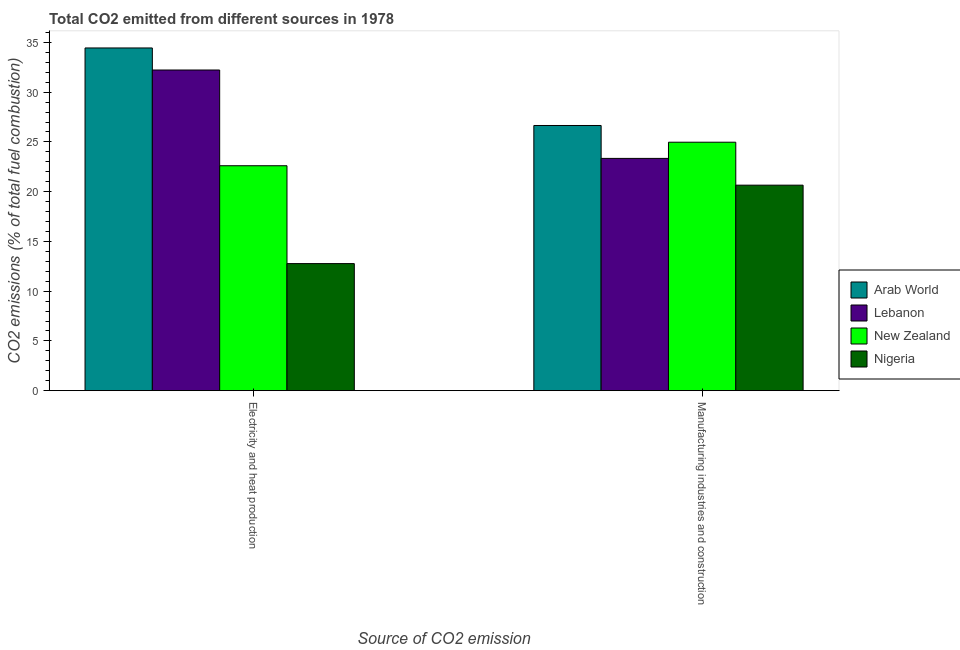How many different coloured bars are there?
Make the answer very short. 4. Are the number of bars per tick equal to the number of legend labels?
Give a very brief answer. Yes. Are the number of bars on each tick of the X-axis equal?
Offer a terse response. Yes. How many bars are there on the 2nd tick from the right?
Keep it short and to the point. 4. What is the label of the 2nd group of bars from the left?
Provide a short and direct response. Manufacturing industries and construction. What is the co2 emissions due to manufacturing industries in New Zealand?
Your answer should be compact. 24.97. Across all countries, what is the maximum co2 emissions due to electricity and heat production?
Provide a succinct answer. 34.45. Across all countries, what is the minimum co2 emissions due to electricity and heat production?
Give a very brief answer. 12.77. In which country was the co2 emissions due to electricity and heat production maximum?
Provide a short and direct response. Arab World. In which country was the co2 emissions due to manufacturing industries minimum?
Offer a terse response. Nigeria. What is the total co2 emissions due to electricity and heat production in the graph?
Offer a very short reply. 102.05. What is the difference between the co2 emissions due to electricity and heat production in Arab World and that in New Zealand?
Keep it short and to the point. 11.84. What is the difference between the co2 emissions due to manufacturing industries in Lebanon and the co2 emissions due to electricity and heat production in Arab World?
Your answer should be compact. -11.1. What is the average co2 emissions due to electricity and heat production per country?
Provide a short and direct response. 25.51. What is the difference between the co2 emissions due to electricity and heat production and co2 emissions due to manufacturing industries in Lebanon?
Provide a short and direct response. 8.89. What is the ratio of the co2 emissions due to manufacturing industries in Nigeria to that in Lebanon?
Offer a terse response. 0.88. What does the 3rd bar from the left in Manufacturing industries and construction represents?
Provide a succinct answer. New Zealand. What does the 1st bar from the right in Manufacturing industries and construction represents?
Ensure brevity in your answer.  Nigeria. How many bars are there?
Make the answer very short. 8. What is the difference between two consecutive major ticks on the Y-axis?
Give a very brief answer. 5. Are the values on the major ticks of Y-axis written in scientific E-notation?
Your answer should be very brief. No. Does the graph contain grids?
Make the answer very short. No. Where does the legend appear in the graph?
Provide a short and direct response. Center right. How are the legend labels stacked?
Your answer should be compact. Vertical. What is the title of the graph?
Provide a short and direct response. Total CO2 emitted from different sources in 1978. Does "Netherlands" appear as one of the legend labels in the graph?
Provide a succinct answer. No. What is the label or title of the X-axis?
Your response must be concise. Source of CO2 emission. What is the label or title of the Y-axis?
Give a very brief answer. CO2 emissions (% of total fuel combustion). What is the CO2 emissions (% of total fuel combustion) of Arab World in Electricity and heat production?
Provide a short and direct response. 34.45. What is the CO2 emissions (% of total fuel combustion) of Lebanon in Electricity and heat production?
Offer a terse response. 32.23. What is the CO2 emissions (% of total fuel combustion) in New Zealand in Electricity and heat production?
Offer a very short reply. 22.61. What is the CO2 emissions (% of total fuel combustion) in Nigeria in Electricity and heat production?
Ensure brevity in your answer.  12.77. What is the CO2 emissions (% of total fuel combustion) of Arab World in Manufacturing industries and construction?
Offer a very short reply. 26.65. What is the CO2 emissions (% of total fuel combustion) in Lebanon in Manufacturing industries and construction?
Keep it short and to the point. 23.34. What is the CO2 emissions (% of total fuel combustion) of New Zealand in Manufacturing industries and construction?
Make the answer very short. 24.97. What is the CO2 emissions (% of total fuel combustion) in Nigeria in Manufacturing industries and construction?
Your answer should be compact. 20.65. Across all Source of CO2 emission, what is the maximum CO2 emissions (% of total fuel combustion) in Arab World?
Ensure brevity in your answer.  34.45. Across all Source of CO2 emission, what is the maximum CO2 emissions (% of total fuel combustion) in Lebanon?
Provide a short and direct response. 32.23. Across all Source of CO2 emission, what is the maximum CO2 emissions (% of total fuel combustion) of New Zealand?
Your response must be concise. 24.97. Across all Source of CO2 emission, what is the maximum CO2 emissions (% of total fuel combustion) of Nigeria?
Provide a succinct answer. 20.65. Across all Source of CO2 emission, what is the minimum CO2 emissions (% of total fuel combustion) in Arab World?
Offer a terse response. 26.65. Across all Source of CO2 emission, what is the minimum CO2 emissions (% of total fuel combustion) in Lebanon?
Provide a succinct answer. 23.34. Across all Source of CO2 emission, what is the minimum CO2 emissions (% of total fuel combustion) in New Zealand?
Give a very brief answer. 22.61. Across all Source of CO2 emission, what is the minimum CO2 emissions (% of total fuel combustion) of Nigeria?
Provide a short and direct response. 12.77. What is the total CO2 emissions (% of total fuel combustion) of Arab World in the graph?
Your answer should be compact. 61.1. What is the total CO2 emissions (% of total fuel combustion) of Lebanon in the graph?
Provide a short and direct response. 55.57. What is the total CO2 emissions (% of total fuel combustion) of New Zealand in the graph?
Your answer should be very brief. 47.58. What is the total CO2 emissions (% of total fuel combustion) of Nigeria in the graph?
Give a very brief answer. 33.43. What is the difference between the CO2 emissions (% of total fuel combustion) in Arab World in Electricity and heat production and that in Manufacturing industries and construction?
Your response must be concise. 7.79. What is the difference between the CO2 emissions (% of total fuel combustion) in Lebanon in Electricity and heat production and that in Manufacturing industries and construction?
Ensure brevity in your answer.  8.88. What is the difference between the CO2 emissions (% of total fuel combustion) of New Zealand in Electricity and heat production and that in Manufacturing industries and construction?
Your answer should be very brief. -2.37. What is the difference between the CO2 emissions (% of total fuel combustion) in Nigeria in Electricity and heat production and that in Manufacturing industries and construction?
Provide a succinct answer. -7.88. What is the difference between the CO2 emissions (% of total fuel combustion) of Arab World in Electricity and heat production and the CO2 emissions (% of total fuel combustion) of Lebanon in Manufacturing industries and construction?
Make the answer very short. 11.1. What is the difference between the CO2 emissions (% of total fuel combustion) in Arab World in Electricity and heat production and the CO2 emissions (% of total fuel combustion) in New Zealand in Manufacturing industries and construction?
Ensure brevity in your answer.  9.47. What is the difference between the CO2 emissions (% of total fuel combustion) of Arab World in Electricity and heat production and the CO2 emissions (% of total fuel combustion) of Nigeria in Manufacturing industries and construction?
Your answer should be compact. 13.79. What is the difference between the CO2 emissions (% of total fuel combustion) in Lebanon in Electricity and heat production and the CO2 emissions (% of total fuel combustion) in New Zealand in Manufacturing industries and construction?
Your answer should be very brief. 7.26. What is the difference between the CO2 emissions (% of total fuel combustion) in Lebanon in Electricity and heat production and the CO2 emissions (% of total fuel combustion) in Nigeria in Manufacturing industries and construction?
Your answer should be very brief. 11.58. What is the difference between the CO2 emissions (% of total fuel combustion) of New Zealand in Electricity and heat production and the CO2 emissions (% of total fuel combustion) of Nigeria in Manufacturing industries and construction?
Ensure brevity in your answer.  1.95. What is the average CO2 emissions (% of total fuel combustion) in Arab World per Source of CO2 emission?
Make the answer very short. 30.55. What is the average CO2 emissions (% of total fuel combustion) in Lebanon per Source of CO2 emission?
Keep it short and to the point. 27.79. What is the average CO2 emissions (% of total fuel combustion) in New Zealand per Source of CO2 emission?
Offer a very short reply. 23.79. What is the average CO2 emissions (% of total fuel combustion) of Nigeria per Source of CO2 emission?
Provide a succinct answer. 16.71. What is the difference between the CO2 emissions (% of total fuel combustion) of Arab World and CO2 emissions (% of total fuel combustion) of Lebanon in Electricity and heat production?
Make the answer very short. 2.22. What is the difference between the CO2 emissions (% of total fuel combustion) of Arab World and CO2 emissions (% of total fuel combustion) of New Zealand in Electricity and heat production?
Make the answer very short. 11.84. What is the difference between the CO2 emissions (% of total fuel combustion) in Arab World and CO2 emissions (% of total fuel combustion) in Nigeria in Electricity and heat production?
Offer a very short reply. 21.67. What is the difference between the CO2 emissions (% of total fuel combustion) in Lebanon and CO2 emissions (% of total fuel combustion) in New Zealand in Electricity and heat production?
Give a very brief answer. 9.62. What is the difference between the CO2 emissions (% of total fuel combustion) in Lebanon and CO2 emissions (% of total fuel combustion) in Nigeria in Electricity and heat production?
Give a very brief answer. 19.46. What is the difference between the CO2 emissions (% of total fuel combustion) of New Zealand and CO2 emissions (% of total fuel combustion) of Nigeria in Electricity and heat production?
Give a very brief answer. 9.84. What is the difference between the CO2 emissions (% of total fuel combustion) of Arab World and CO2 emissions (% of total fuel combustion) of Lebanon in Manufacturing industries and construction?
Offer a terse response. 3.31. What is the difference between the CO2 emissions (% of total fuel combustion) in Arab World and CO2 emissions (% of total fuel combustion) in New Zealand in Manufacturing industries and construction?
Your answer should be very brief. 1.68. What is the difference between the CO2 emissions (% of total fuel combustion) of Arab World and CO2 emissions (% of total fuel combustion) of Nigeria in Manufacturing industries and construction?
Keep it short and to the point. 6. What is the difference between the CO2 emissions (% of total fuel combustion) in Lebanon and CO2 emissions (% of total fuel combustion) in New Zealand in Manufacturing industries and construction?
Provide a short and direct response. -1.63. What is the difference between the CO2 emissions (% of total fuel combustion) of Lebanon and CO2 emissions (% of total fuel combustion) of Nigeria in Manufacturing industries and construction?
Offer a terse response. 2.69. What is the difference between the CO2 emissions (% of total fuel combustion) of New Zealand and CO2 emissions (% of total fuel combustion) of Nigeria in Manufacturing industries and construction?
Offer a very short reply. 4.32. What is the ratio of the CO2 emissions (% of total fuel combustion) in Arab World in Electricity and heat production to that in Manufacturing industries and construction?
Your response must be concise. 1.29. What is the ratio of the CO2 emissions (% of total fuel combustion) of Lebanon in Electricity and heat production to that in Manufacturing industries and construction?
Your answer should be very brief. 1.38. What is the ratio of the CO2 emissions (% of total fuel combustion) of New Zealand in Electricity and heat production to that in Manufacturing industries and construction?
Your answer should be very brief. 0.91. What is the ratio of the CO2 emissions (% of total fuel combustion) in Nigeria in Electricity and heat production to that in Manufacturing industries and construction?
Your answer should be very brief. 0.62. What is the difference between the highest and the second highest CO2 emissions (% of total fuel combustion) of Arab World?
Ensure brevity in your answer.  7.79. What is the difference between the highest and the second highest CO2 emissions (% of total fuel combustion) of Lebanon?
Offer a terse response. 8.88. What is the difference between the highest and the second highest CO2 emissions (% of total fuel combustion) of New Zealand?
Your answer should be compact. 2.37. What is the difference between the highest and the second highest CO2 emissions (% of total fuel combustion) in Nigeria?
Your answer should be compact. 7.88. What is the difference between the highest and the lowest CO2 emissions (% of total fuel combustion) of Arab World?
Your answer should be very brief. 7.79. What is the difference between the highest and the lowest CO2 emissions (% of total fuel combustion) in Lebanon?
Your answer should be very brief. 8.88. What is the difference between the highest and the lowest CO2 emissions (% of total fuel combustion) of New Zealand?
Offer a very short reply. 2.37. What is the difference between the highest and the lowest CO2 emissions (% of total fuel combustion) in Nigeria?
Keep it short and to the point. 7.88. 